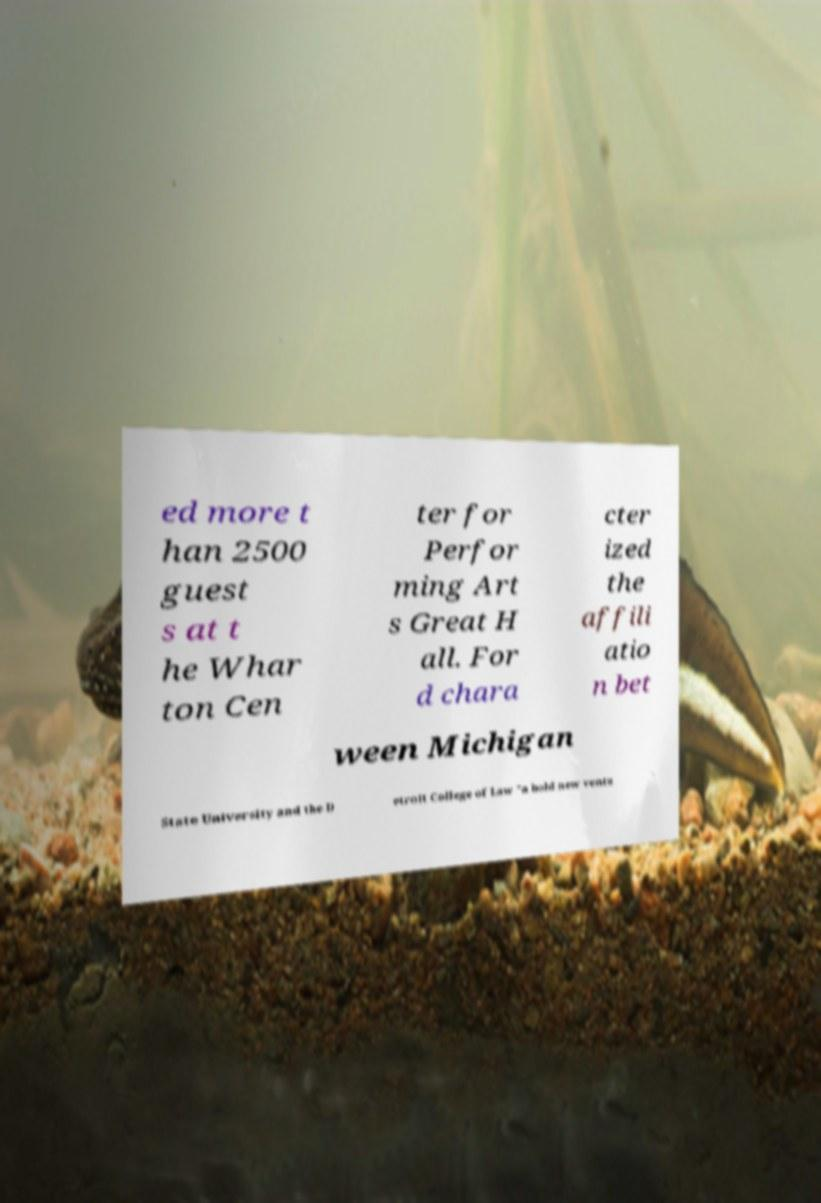For documentation purposes, I need the text within this image transcribed. Could you provide that? ed more t han 2500 guest s at t he Whar ton Cen ter for Perfor ming Art s Great H all. For d chara cter ized the affili atio n bet ween Michigan State University and the D etroit College of Law "a bold new ventu 